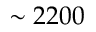Convert formula to latex. <formula><loc_0><loc_0><loc_500><loc_500>\sim 2 2 0 0</formula> 